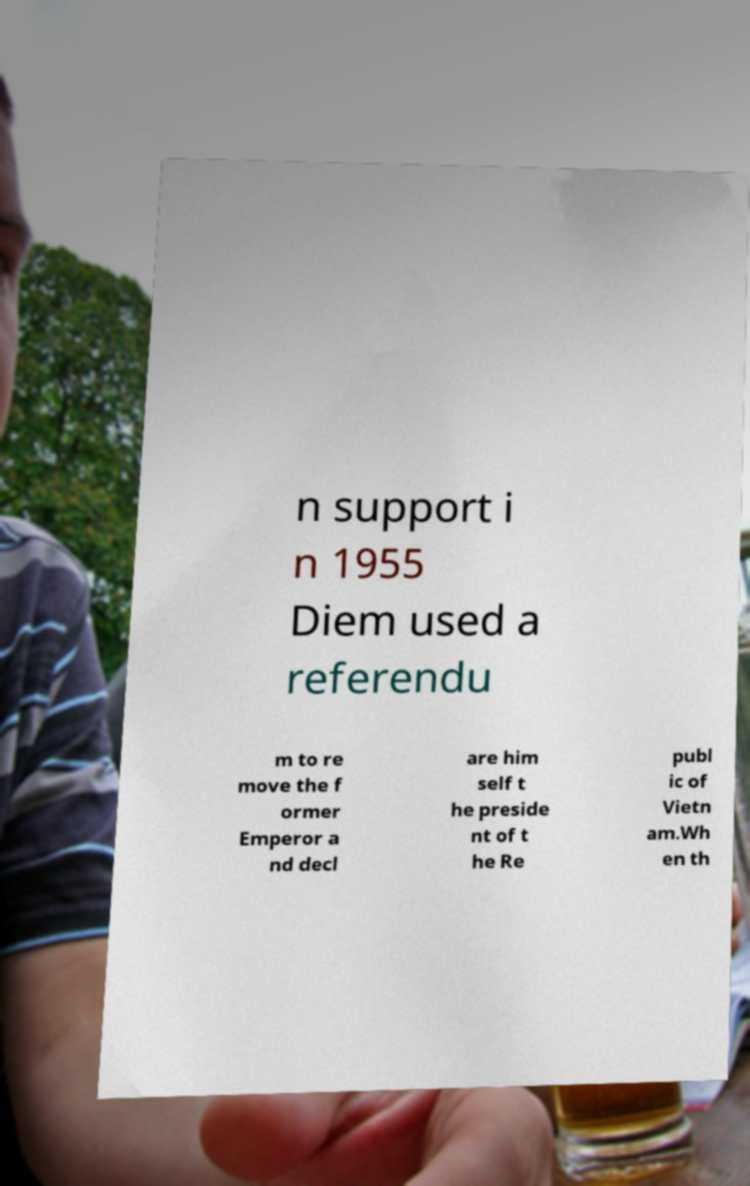Please read and relay the text visible in this image. What does it say? n support i n 1955 Diem used a referendu m to re move the f ormer Emperor a nd decl are him self t he preside nt of t he Re publ ic of Vietn am.Wh en th 